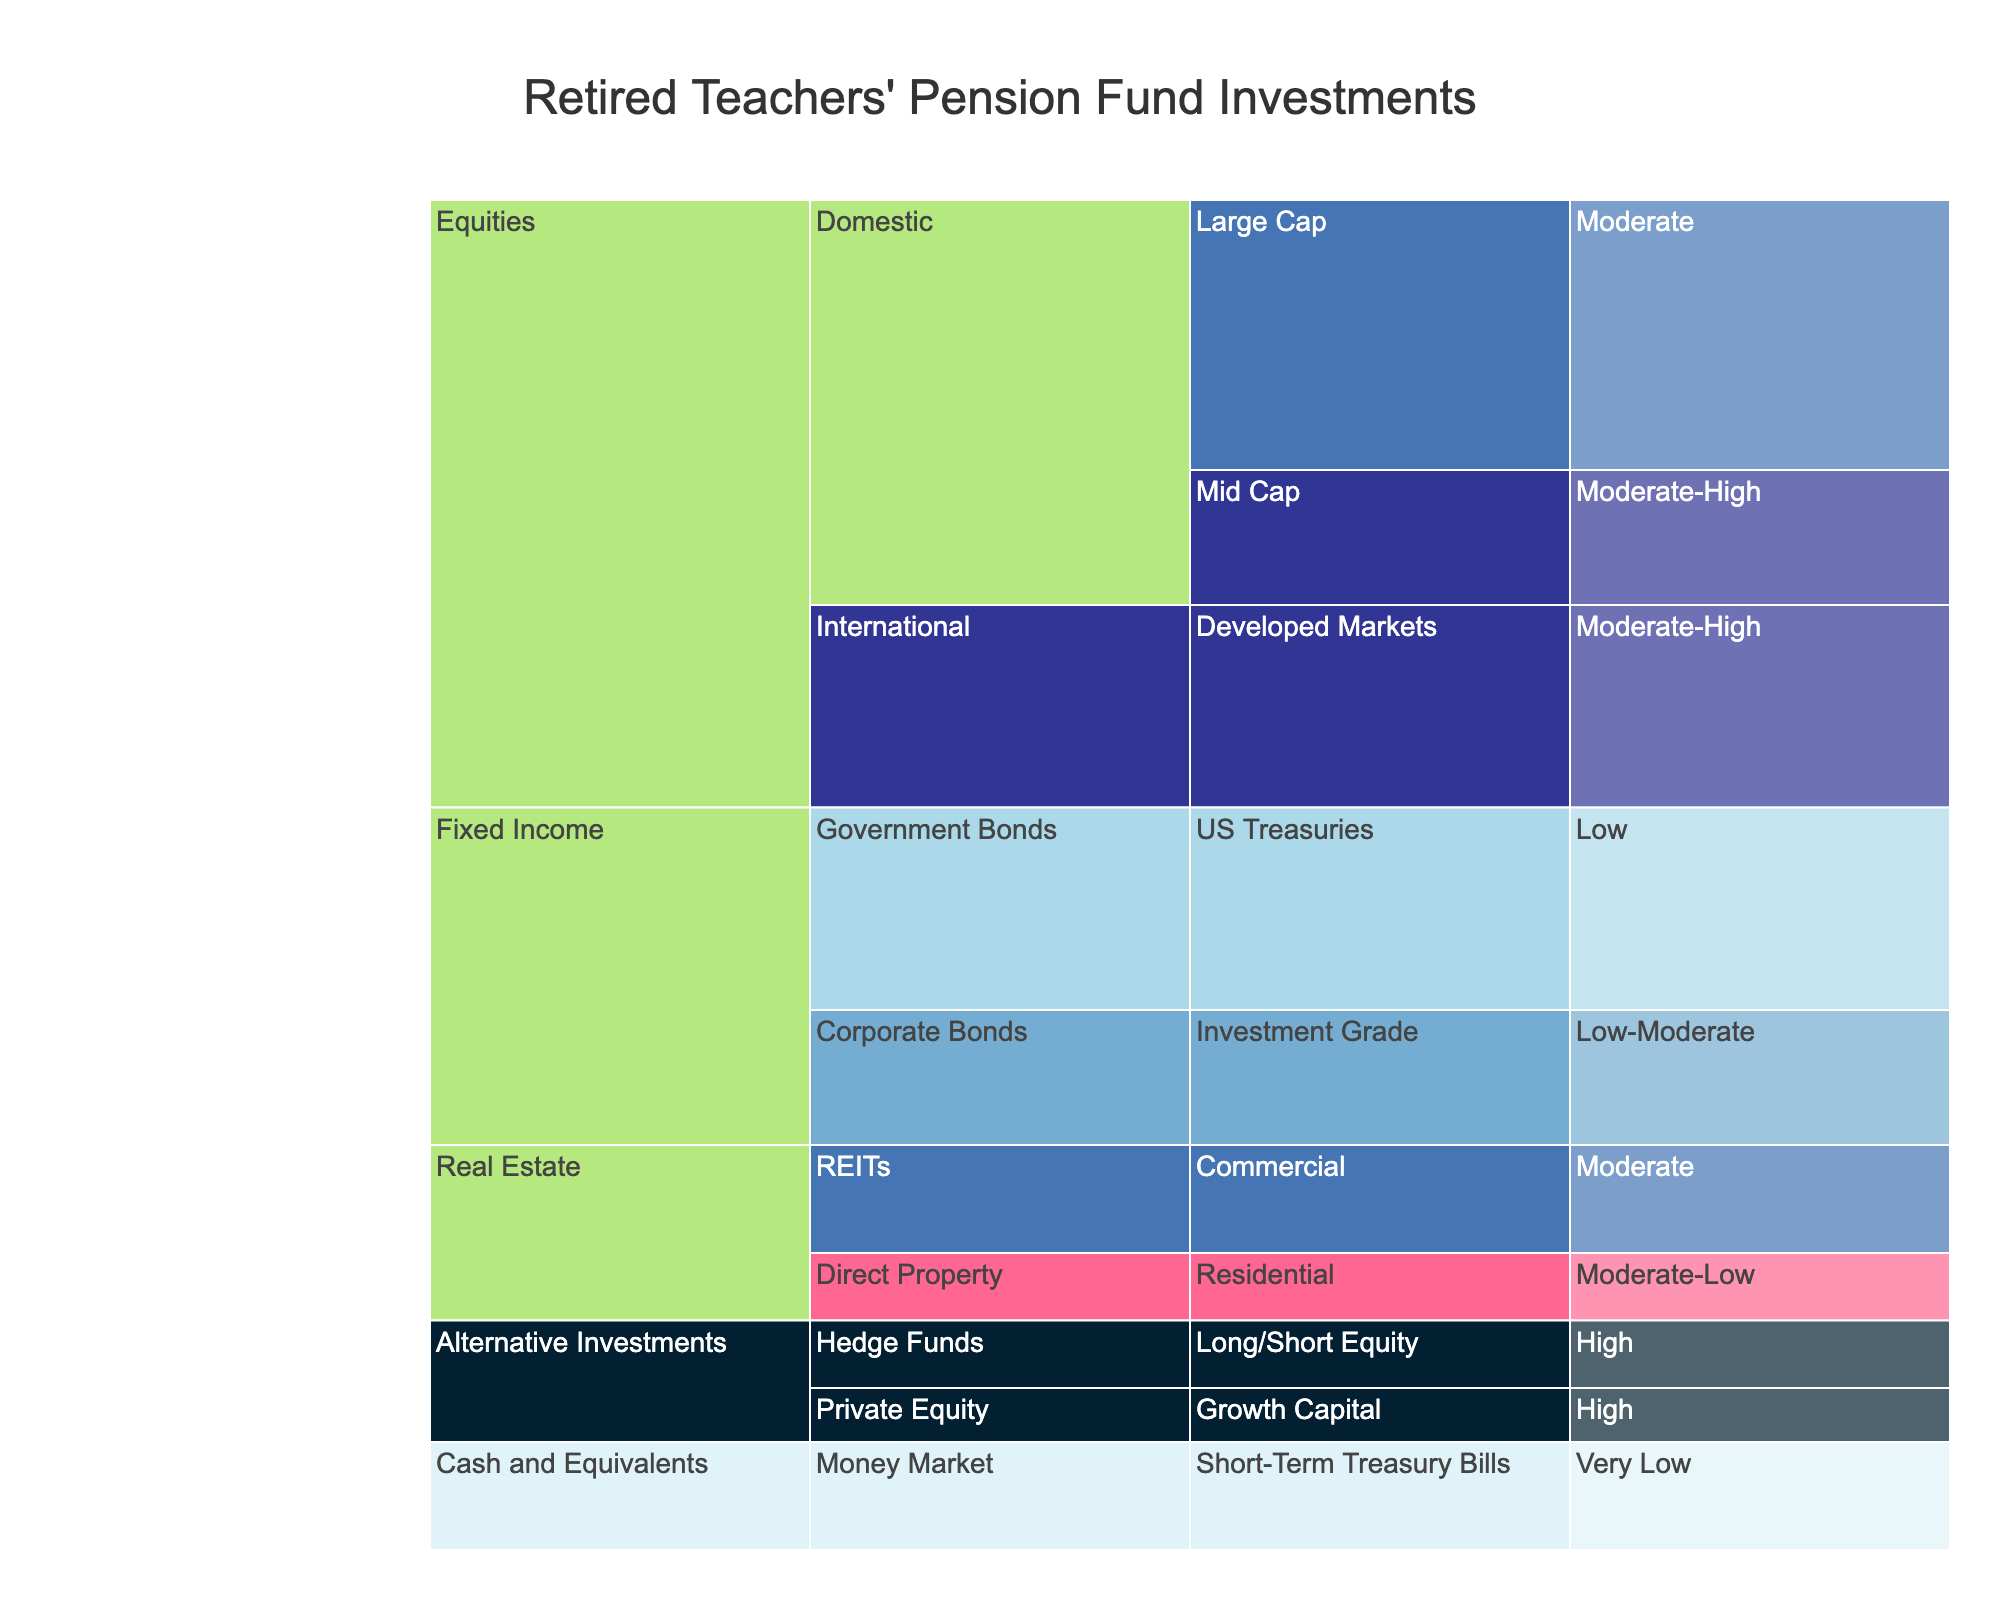What is the title of the Icicle Chart? The title is located at the top of the chart and often summarizes the main focus of the visualization. The title here reads "Retired Teachers' Pension Fund Investments".
Answer: Retired Teachers' Pension Fund Investments How much percentage is allocated to high-risk level investments? In the icicle chart, the "High" risk level category includes Hedge Funds (5%) and Private Equity (4%). Summing these percentages gives us 5% + 4% = 9%.
Answer: 9% Which asset class has the largest allocation percentage and what is it? By visual inspection, the largest section in the chart is Equities, which has multiple sub-categories. The total allocation percentage within Equities is 20% (Domestic Large Cap) + 10% (Domestic Mid Cap) + 15% (International Developed Markets) = 45%.
Answer: Equities, 45% Compare the percentage allocation of Domestic Large Cap equities to US Treasuries under government bonds. From the figure, Domestic Large Cap equities have 20% allocation while US Treasuries under Government Bonds have 15%. Comparing these, 20% is greater than 15%.
Answer: Domestic Large Cap equities have a higher allocation than US Treasuries What is the allocation percentage for Real Estate and how is it divided? Real estate is divided into REITs (8%) and Direct Property (5%). Adding these up gives us 8% + 5% = 13%.
Answer: 13%: REITs 8%, Direct Property 5% Which sub-category within Fixed Income has the lowest risk, and what is its allocation percentage? Within Fixed Income, US Treasuries fall under the "Low" risk level, and its allocation is 15%.
Answer: US Treasuries, 15% Identify the category with the smallest total allocation and specify the amount. Alternative Investments comprises Hedge Funds (5%) and Private Equity (4%). The total is 5% + 4% = 9%, which is the smallest allocation in the chart.
Answer: Alternative Investments, 9% How are the categories in the chart color-coded in terms of risk level? The colors represent different risk levels: 'Very Low' (light blue), 'Low' (light shade of blue), 'Low-Moderate' (medium blue), 'Moderate' (dark blue), 'Moderate-High' (darker blue), and 'High' (darkest blue). This color scheme helps to visually distinguish the risk levels.
Answer: Colors range from light blue (Very Low) to darkest blue (High) What is the sum of percentages allocated to Moderate risk level investments? Moderate risk investments include Domestic Large Cap (20%) and REITs (8%), summing these values gives 20% + 8% = 28%.
Answer: 28% Is there any category or sub-category that falls under the "Very Low" risk level, and if so, what is it? The distribution shows "Cash and Equivalents" under "Money Market" with the sub-category "Short-Term Treasury Bills" allocated 8% at a "Very Low" risk level.
Answer: Short-Term Treasury Bills, 8% 